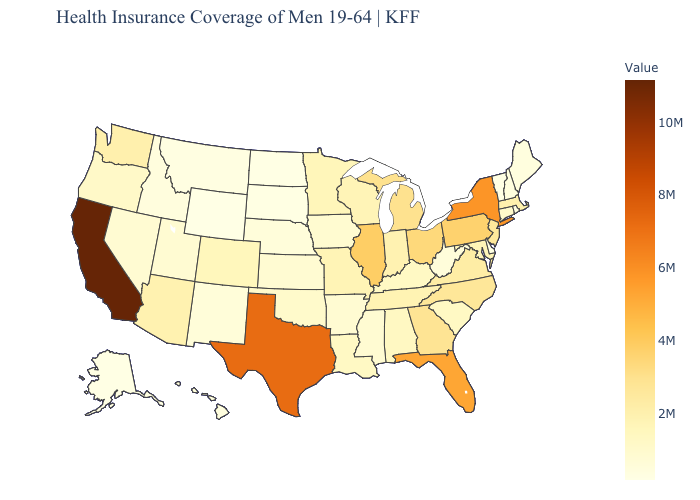Which states have the lowest value in the USA?
Be succinct. Wyoming. Does Wyoming have the lowest value in the USA?
Be succinct. Yes. Does Idaho have the highest value in the USA?
Write a very short answer. No. Does Nebraska have a higher value than Florida?
Write a very short answer. No. Which states hav the highest value in the Northeast?
Keep it brief. New York. 